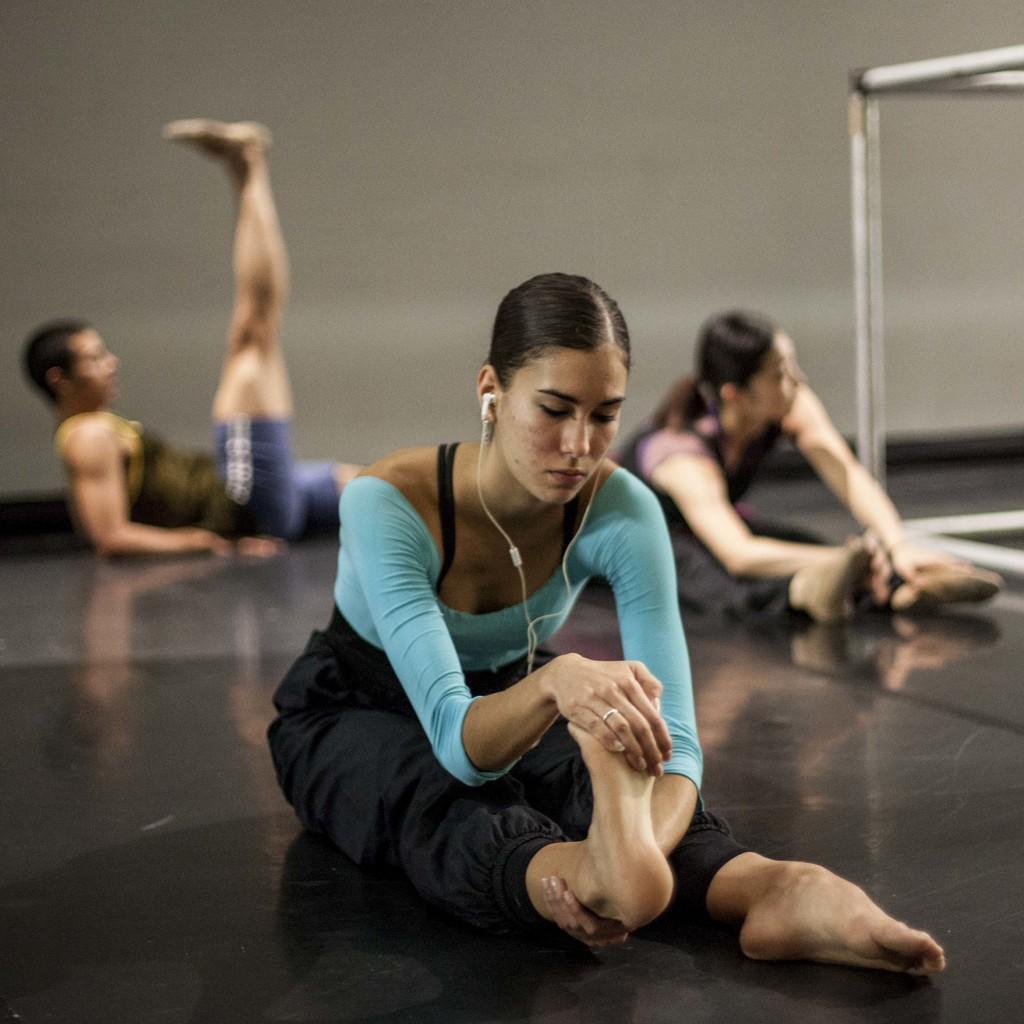How would you summarize this image in a sentence or two? In this image I can see a woman wearing blue and black colored dress is sitting on the black colored floor. In the background I can see a person lying and another person sitting, few metal poles and the wall. 